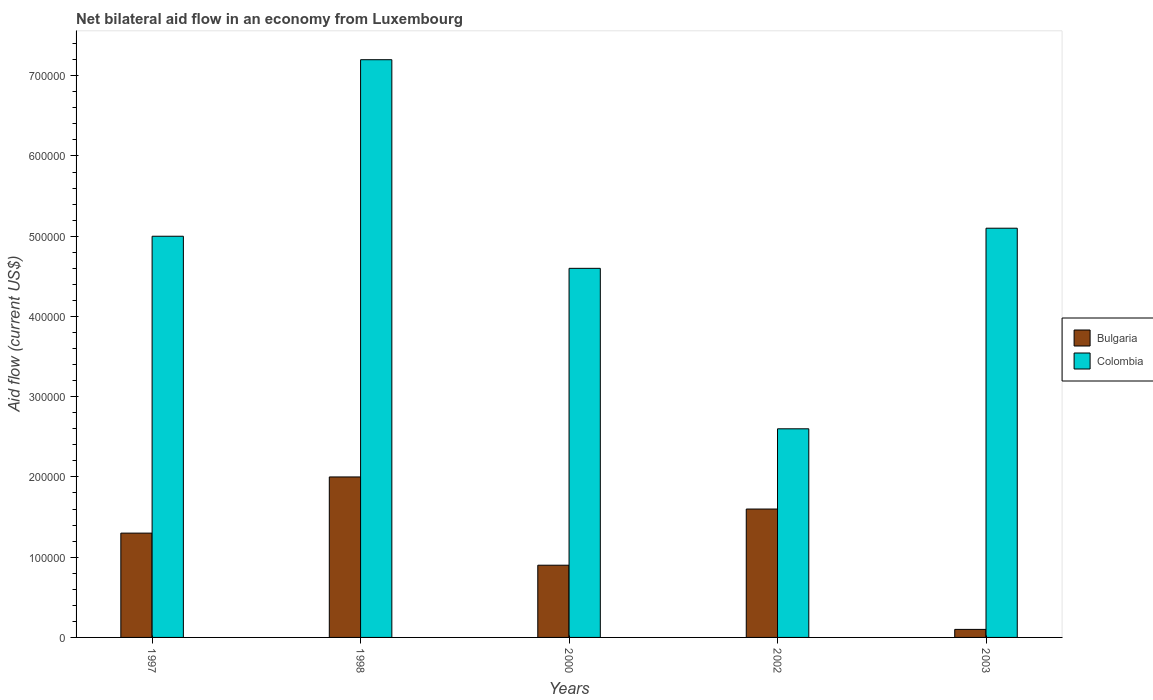How many groups of bars are there?
Keep it short and to the point. 5. Are the number of bars per tick equal to the number of legend labels?
Your answer should be compact. Yes. How many bars are there on the 3rd tick from the left?
Ensure brevity in your answer.  2. How many bars are there on the 3rd tick from the right?
Offer a terse response. 2. Across all years, what is the maximum net bilateral aid flow in Colombia?
Offer a very short reply. 7.20e+05. What is the total net bilateral aid flow in Bulgaria in the graph?
Offer a very short reply. 5.90e+05. What is the difference between the net bilateral aid flow in Bulgaria in 2003 and the net bilateral aid flow in Colombia in 1997?
Provide a short and direct response. -4.90e+05. What is the average net bilateral aid flow in Bulgaria per year?
Make the answer very short. 1.18e+05. In the year 2000, what is the difference between the net bilateral aid flow in Bulgaria and net bilateral aid flow in Colombia?
Ensure brevity in your answer.  -3.70e+05. In how many years, is the net bilateral aid flow in Bulgaria greater than 360000 US$?
Your response must be concise. 0. Is the net bilateral aid flow in Colombia in 1998 less than that in 2002?
Ensure brevity in your answer.  No. What does the 1st bar from the left in 1997 represents?
Your response must be concise. Bulgaria. Are all the bars in the graph horizontal?
Your response must be concise. No. How many years are there in the graph?
Keep it short and to the point. 5. Are the values on the major ticks of Y-axis written in scientific E-notation?
Offer a terse response. No. How many legend labels are there?
Offer a very short reply. 2. How are the legend labels stacked?
Your response must be concise. Vertical. What is the title of the graph?
Ensure brevity in your answer.  Net bilateral aid flow in an economy from Luxembourg. What is the Aid flow (current US$) of Bulgaria in 1997?
Ensure brevity in your answer.  1.30e+05. What is the Aid flow (current US$) of Bulgaria in 1998?
Give a very brief answer. 2.00e+05. What is the Aid flow (current US$) of Colombia in 1998?
Your response must be concise. 7.20e+05. What is the Aid flow (current US$) of Bulgaria in 2000?
Your answer should be very brief. 9.00e+04. What is the Aid flow (current US$) of Colombia in 2002?
Give a very brief answer. 2.60e+05. What is the Aid flow (current US$) of Bulgaria in 2003?
Make the answer very short. 10000. What is the Aid flow (current US$) of Colombia in 2003?
Provide a short and direct response. 5.10e+05. Across all years, what is the maximum Aid flow (current US$) of Bulgaria?
Offer a terse response. 2.00e+05. Across all years, what is the maximum Aid flow (current US$) in Colombia?
Your response must be concise. 7.20e+05. Across all years, what is the minimum Aid flow (current US$) of Colombia?
Give a very brief answer. 2.60e+05. What is the total Aid flow (current US$) of Bulgaria in the graph?
Make the answer very short. 5.90e+05. What is the total Aid flow (current US$) of Colombia in the graph?
Make the answer very short. 2.45e+06. What is the difference between the Aid flow (current US$) in Bulgaria in 1997 and that in 2000?
Give a very brief answer. 4.00e+04. What is the difference between the Aid flow (current US$) in Colombia in 1997 and that in 2000?
Provide a short and direct response. 4.00e+04. What is the difference between the Aid flow (current US$) of Bulgaria in 1997 and that in 2002?
Your answer should be compact. -3.00e+04. What is the difference between the Aid flow (current US$) of Bulgaria in 1997 and that in 2003?
Make the answer very short. 1.20e+05. What is the difference between the Aid flow (current US$) in Bulgaria in 1998 and that in 2000?
Make the answer very short. 1.10e+05. What is the difference between the Aid flow (current US$) of Colombia in 1998 and that in 2000?
Your answer should be very brief. 2.60e+05. What is the difference between the Aid flow (current US$) of Bulgaria in 1998 and that in 2003?
Provide a succinct answer. 1.90e+05. What is the difference between the Aid flow (current US$) in Bulgaria in 2000 and that in 2003?
Your response must be concise. 8.00e+04. What is the difference between the Aid flow (current US$) in Colombia in 2000 and that in 2003?
Give a very brief answer. -5.00e+04. What is the difference between the Aid flow (current US$) of Colombia in 2002 and that in 2003?
Provide a succinct answer. -2.50e+05. What is the difference between the Aid flow (current US$) of Bulgaria in 1997 and the Aid flow (current US$) of Colombia in 1998?
Offer a terse response. -5.90e+05. What is the difference between the Aid flow (current US$) in Bulgaria in 1997 and the Aid flow (current US$) in Colombia in 2000?
Your response must be concise. -3.30e+05. What is the difference between the Aid flow (current US$) of Bulgaria in 1997 and the Aid flow (current US$) of Colombia in 2003?
Your answer should be very brief. -3.80e+05. What is the difference between the Aid flow (current US$) in Bulgaria in 1998 and the Aid flow (current US$) in Colombia in 2002?
Keep it short and to the point. -6.00e+04. What is the difference between the Aid flow (current US$) of Bulgaria in 1998 and the Aid flow (current US$) of Colombia in 2003?
Offer a terse response. -3.10e+05. What is the difference between the Aid flow (current US$) of Bulgaria in 2000 and the Aid flow (current US$) of Colombia in 2003?
Offer a very short reply. -4.20e+05. What is the difference between the Aid flow (current US$) in Bulgaria in 2002 and the Aid flow (current US$) in Colombia in 2003?
Offer a terse response. -3.50e+05. What is the average Aid flow (current US$) of Bulgaria per year?
Your response must be concise. 1.18e+05. What is the average Aid flow (current US$) in Colombia per year?
Make the answer very short. 4.90e+05. In the year 1997, what is the difference between the Aid flow (current US$) of Bulgaria and Aid flow (current US$) of Colombia?
Keep it short and to the point. -3.70e+05. In the year 1998, what is the difference between the Aid flow (current US$) of Bulgaria and Aid flow (current US$) of Colombia?
Provide a short and direct response. -5.20e+05. In the year 2000, what is the difference between the Aid flow (current US$) of Bulgaria and Aid flow (current US$) of Colombia?
Provide a succinct answer. -3.70e+05. In the year 2002, what is the difference between the Aid flow (current US$) of Bulgaria and Aid flow (current US$) of Colombia?
Your response must be concise. -1.00e+05. In the year 2003, what is the difference between the Aid flow (current US$) of Bulgaria and Aid flow (current US$) of Colombia?
Make the answer very short. -5.00e+05. What is the ratio of the Aid flow (current US$) of Bulgaria in 1997 to that in 1998?
Offer a very short reply. 0.65. What is the ratio of the Aid flow (current US$) in Colombia in 1997 to that in 1998?
Offer a terse response. 0.69. What is the ratio of the Aid flow (current US$) in Bulgaria in 1997 to that in 2000?
Your answer should be compact. 1.44. What is the ratio of the Aid flow (current US$) in Colombia in 1997 to that in 2000?
Your answer should be very brief. 1.09. What is the ratio of the Aid flow (current US$) in Bulgaria in 1997 to that in 2002?
Your answer should be very brief. 0.81. What is the ratio of the Aid flow (current US$) in Colombia in 1997 to that in 2002?
Your response must be concise. 1.92. What is the ratio of the Aid flow (current US$) of Colombia in 1997 to that in 2003?
Provide a succinct answer. 0.98. What is the ratio of the Aid flow (current US$) in Bulgaria in 1998 to that in 2000?
Keep it short and to the point. 2.22. What is the ratio of the Aid flow (current US$) in Colombia in 1998 to that in 2000?
Make the answer very short. 1.57. What is the ratio of the Aid flow (current US$) in Bulgaria in 1998 to that in 2002?
Your answer should be compact. 1.25. What is the ratio of the Aid flow (current US$) of Colombia in 1998 to that in 2002?
Provide a succinct answer. 2.77. What is the ratio of the Aid flow (current US$) in Bulgaria in 1998 to that in 2003?
Keep it short and to the point. 20. What is the ratio of the Aid flow (current US$) in Colombia in 1998 to that in 2003?
Your response must be concise. 1.41. What is the ratio of the Aid flow (current US$) of Bulgaria in 2000 to that in 2002?
Offer a very short reply. 0.56. What is the ratio of the Aid flow (current US$) of Colombia in 2000 to that in 2002?
Keep it short and to the point. 1.77. What is the ratio of the Aid flow (current US$) of Colombia in 2000 to that in 2003?
Provide a succinct answer. 0.9. What is the ratio of the Aid flow (current US$) of Bulgaria in 2002 to that in 2003?
Offer a very short reply. 16. What is the ratio of the Aid flow (current US$) in Colombia in 2002 to that in 2003?
Provide a succinct answer. 0.51. What is the difference between the highest and the second highest Aid flow (current US$) of Bulgaria?
Provide a short and direct response. 4.00e+04. What is the difference between the highest and the second highest Aid flow (current US$) in Colombia?
Offer a terse response. 2.10e+05. What is the difference between the highest and the lowest Aid flow (current US$) in Colombia?
Your answer should be compact. 4.60e+05. 